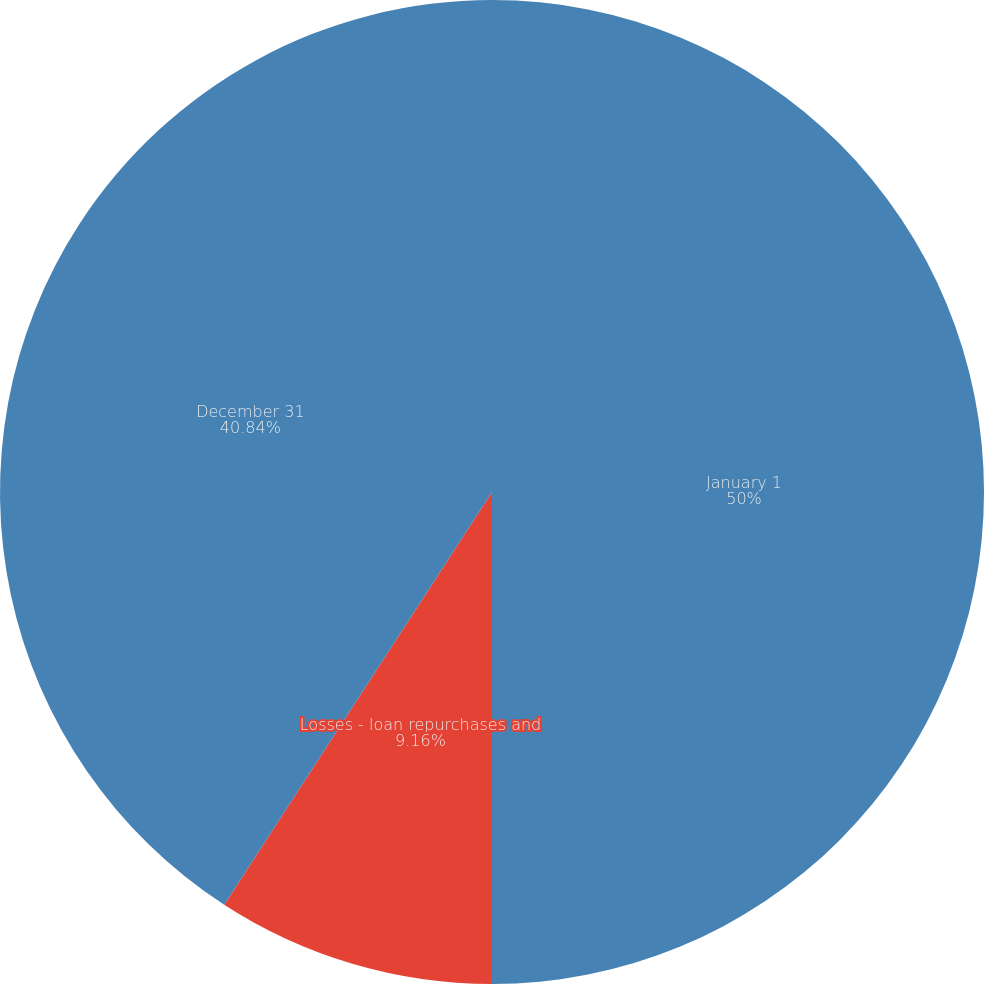Convert chart. <chart><loc_0><loc_0><loc_500><loc_500><pie_chart><fcel>January 1<fcel>Losses - loan repurchases and<fcel>December 31<nl><fcel>50.0%<fcel>9.16%<fcel>40.84%<nl></chart> 